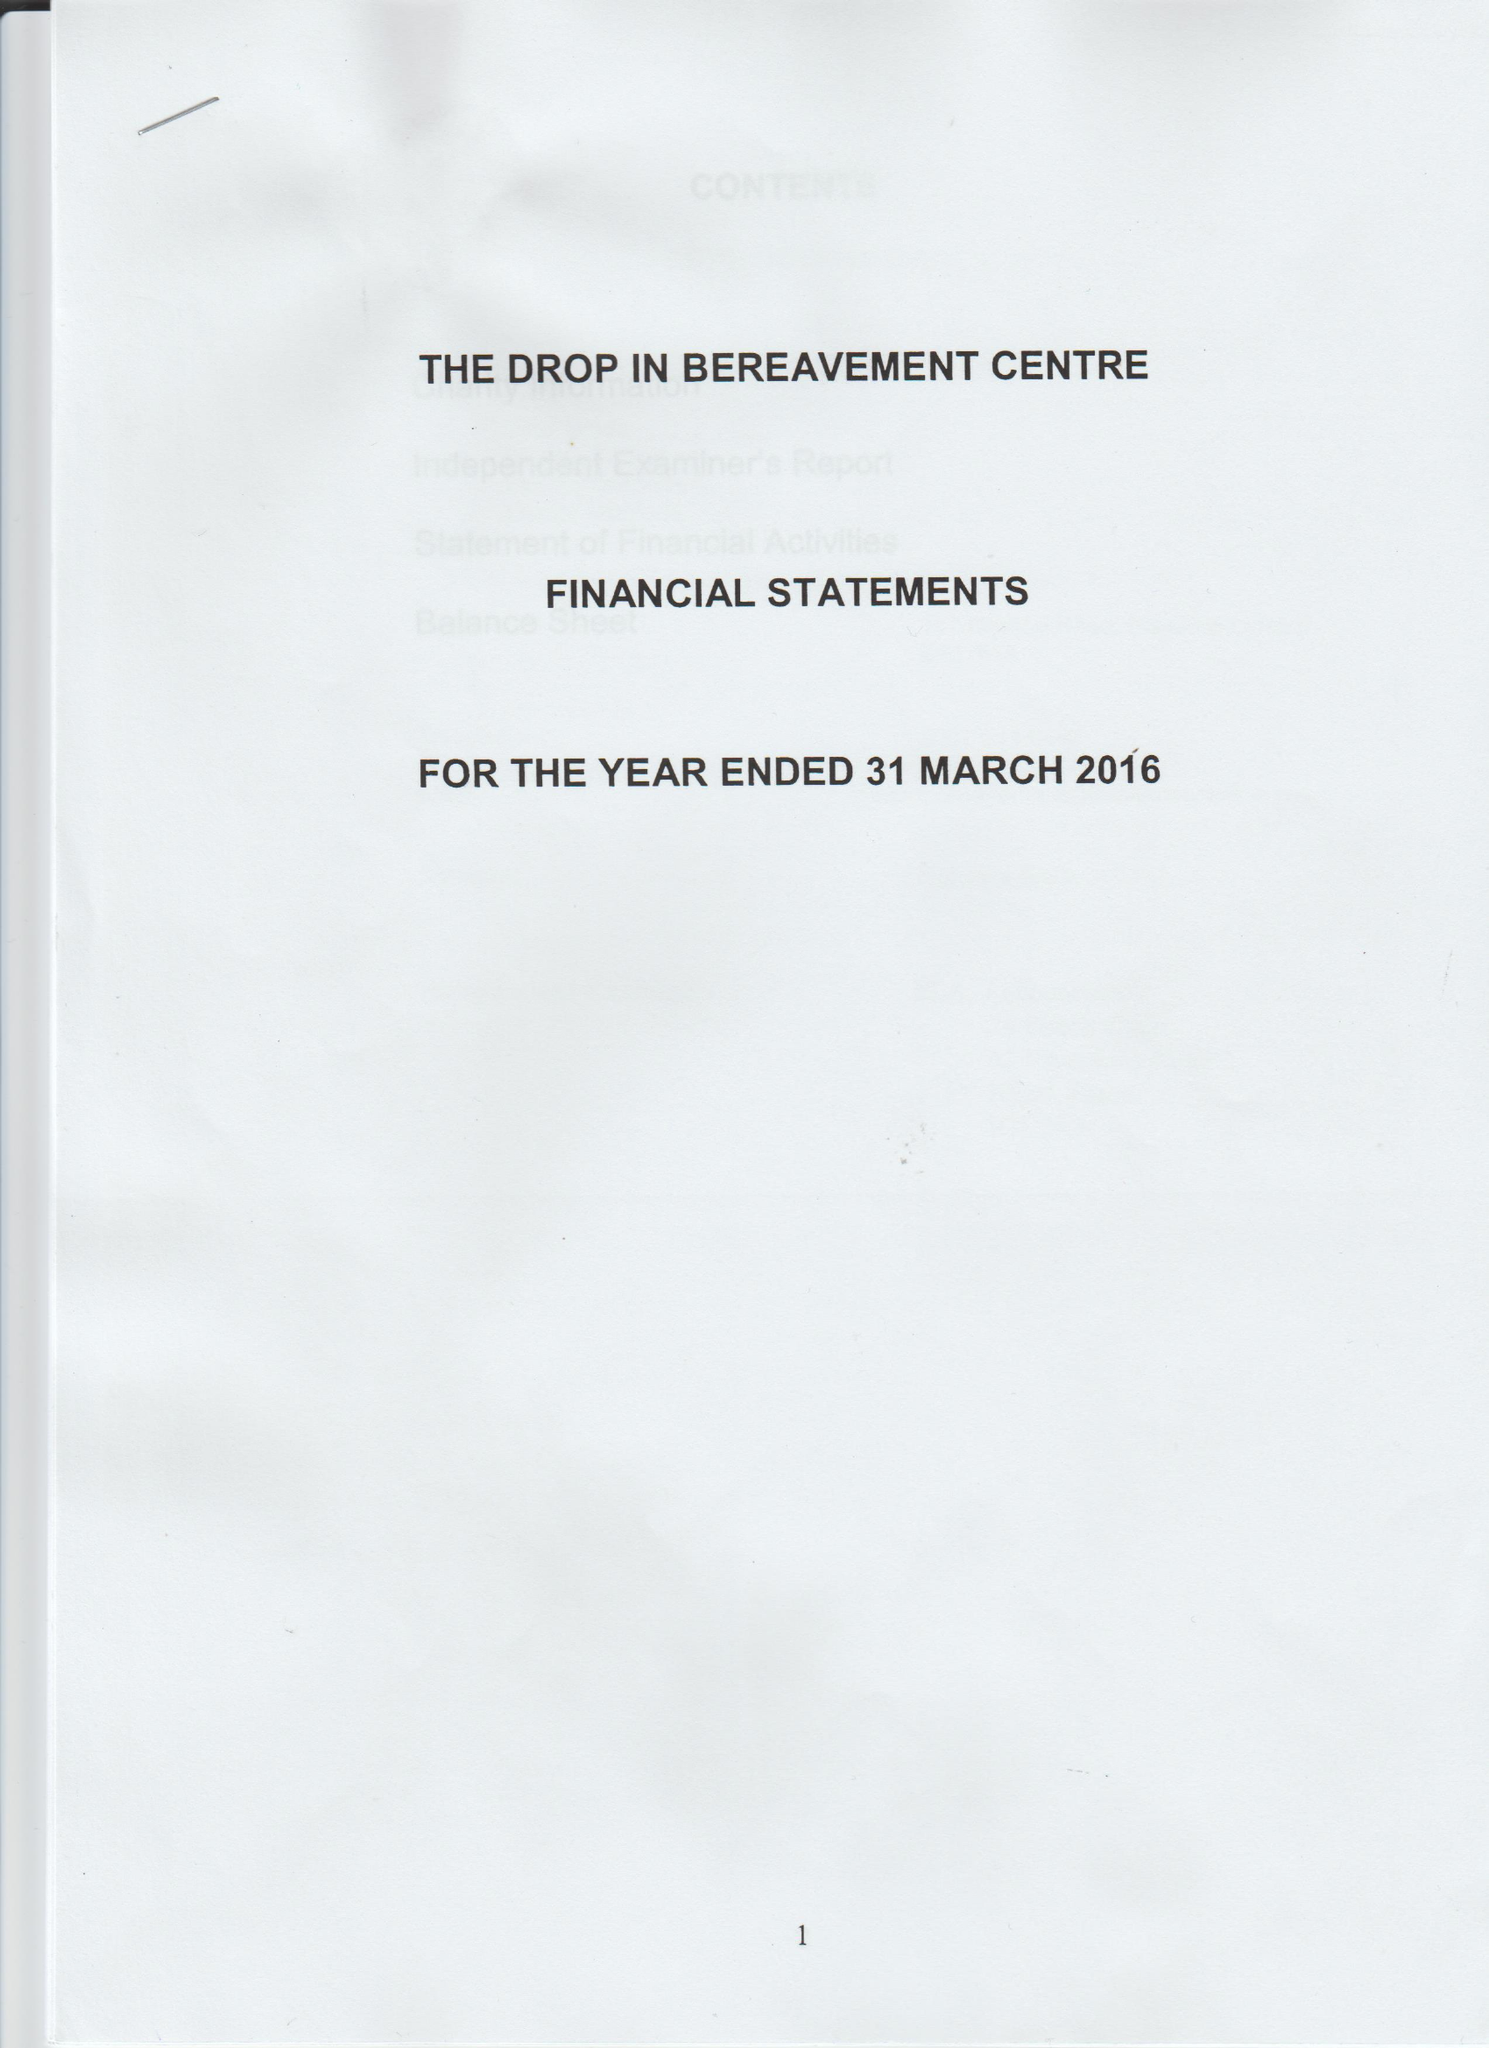What is the value for the report_date?
Answer the question using a single word or phrase. 2016-03-31 